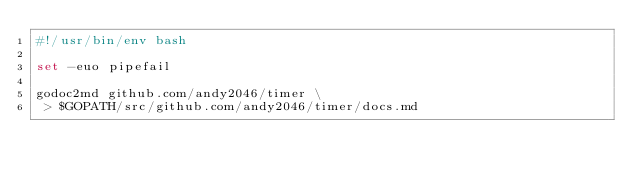Convert code to text. <code><loc_0><loc_0><loc_500><loc_500><_Bash_>#!/usr/bin/env bash

set -euo pipefail

godoc2md github.com/andy2046/timer \
 > $GOPATH/src/github.com/andy2046/timer/docs.md
</code> 